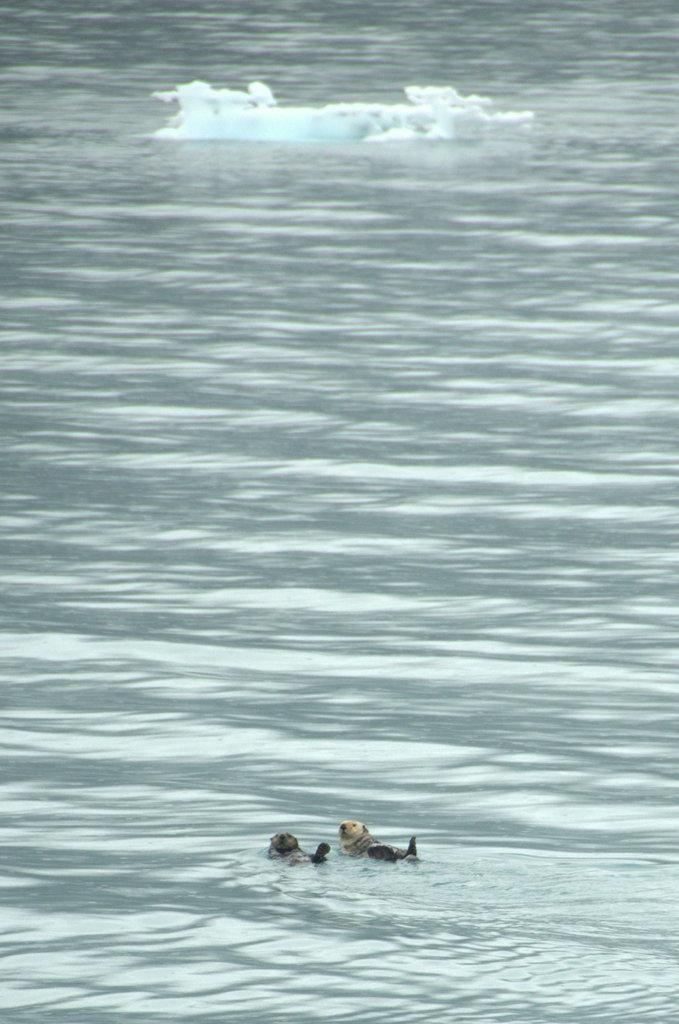What type of animals can be seen in the image? There are marine animals in the water. What is the large, icy object visible at the top of the image? There is an iceberg visible at the top of the image. What type of cup can be seen floating near the marine animals in the image? There is no cup present in the image; it features marine animals and an iceberg. How does the presence of bears in the image affect the behavior of the marine animals? There are no bears present in the image, so their behavior is not affected. 